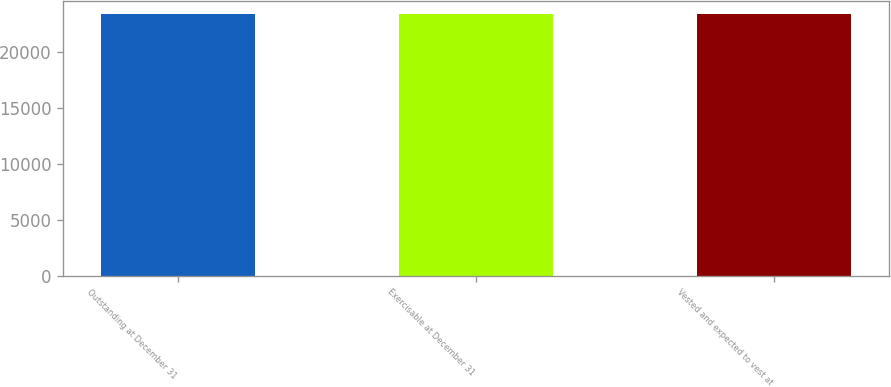<chart> <loc_0><loc_0><loc_500><loc_500><bar_chart><fcel>Outstanding at December 31<fcel>Exercisable at December 31<fcel>Vested and expected to vest at<nl><fcel>23464<fcel>23454<fcel>23463<nl></chart> 